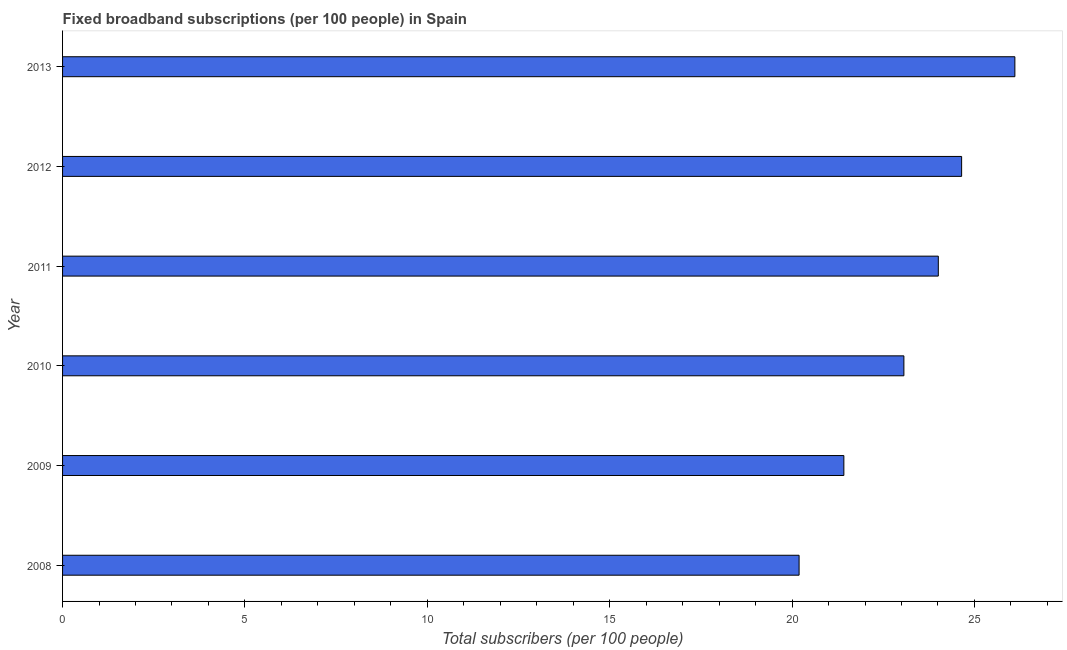Does the graph contain any zero values?
Your response must be concise. No. Does the graph contain grids?
Keep it short and to the point. No. What is the title of the graph?
Provide a succinct answer. Fixed broadband subscriptions (per 100 people) in Spain. What is the label or title of the X-axis?
Offer a very short reply. Total subscribers (per 100 people). What is the total number of fixed broadband subscriptions in 2012?
Your response must be concise. 24.65. Across all years, what is the maximum total number of fixed broadband subscriptions?
Ensure brevity in your answer.  26.11. Across all years, what is the minimum total number of fixed broadband subscriptions?
Your response must be concise. 20.19. In which year was the total number of fixed broadband subscriptions maximum?
Your answer should be very brief. 2013. What is the sum of the total number of fixed broadband subscriptions?
Ensure brevity in your answer.  139.45. What is the difference between the total number of fixed broadband subscriptions in 2010 and 2012?
Offer a terse response. -1.58. What is the average total number of fixed broadband subscriptions per year?
Give a very brief answer. 23.24. What is the median total number of fixed broadband subscriptions?
Offer a very short reply. 23.54. In how many years, is the total number of fixed broadband subscriptions greater than 11 ?
Provide a short and direct response. 6. Do a majority of the years between 2009 and 2011 (inclusive) have total number of fixed broadband subscriptions greater than 23 ?
Make the answer very short. Yes. What is the ratio of the total number of fixed broadband subscriptions in 2009 to that in 2012?
Keep it short and to the point. 0.87. What is the difference between the highest and the second highest total number of fixed broadband subscriptions?
Your answer should be compact. 1.46. Is the sum of the total number of fixed broadband subscriptions in 2011 and 2012 greater than the maximum total number of fixed broadband subscriptions across all years?
Give a very brief answer. Yes. What is the difference between the highest and the lowest total number of fixed broadband subscriptions?
Your response must be concise. 5.92. Are all the bars in the graph horizontal?
Make the answer very short. Yes. What is the difference between two consecutive major ticks on the X-axis?
Give a very brief answer. 5. What is the Total subscribers (per 100 people) of 2008?
Offer a very short reply. 20.19. What is the Total subscribers (per 100 people) in 2009?
Make the answer very short. 21.42. What is the Total subscribers (per 100 people) in 2010?
Your answer should be very brief. 23.07. What is the Total subscribers (per 100 people) in 2011?
Give a very brief answer. 24.01. What is the Total subscribers (per 100 people) in 2012?
Ensure brevity in your answer.  24.65. What is the Total subscribers (per 100 people) in 2013?
Your answer should be very brief. 26.11. What is the difference between the Total subscribers (per 100 people) in 2008 and 2009?
Offer a terse response. -1.23. What is the difference between the Total subscribers (per 100 people) in 2008 and 2010?
Give a very brief answer. -2.87. What is the difference between the Total subscribers (per 100 people) in 2008 and 2011?
Give a very brief answer. -3.82. What is the difference between the Total subscribers (per 100 people) in 2008 and 2012?
Make the answer very short. -4.46. What is the difference between the Total subscribers (per 100 people) in 2008 and 2013?
Offer a terse response. -5.92. What is the difference between the Total subscribers (per 100 people) in 2009 and 2010?
Keep it short and to the point. -1.65. What is the difference between the Total subscribers (per 100 people) in 2009 and 2011?
Provide a succinct answer. -2.59. What is the difference between the Total subscribers (per 100 people) in 2009 and 2012?
Offer a terse response. -3.23. What is the difference between the Total subscribers (per 100 people) in 2009 and 2013?
Provide a short and direct response. -4.69. What is the difference between the Total subscribers (per 100 people) in 2010 and 2011?
Make the answer very short. -0.94. What is the difference between the Total subscribers (per 100 people) in 2010 and 2012?
Offer a terse response. -1.58. What is the difference between the Total subscribers (per 100 people) in 2010 and 2013?
Offer a terse response. -3.04. What is the difference between the Total subscribers (per 100 people) in 2011 and 2012?
Give a very brief answer. -0.64. What is the difference between the Total subscribers (per 100 people) in 2011 and 2013?
Offer a terse response. -2.1. What is the difference between the Total subscribers (per 100 people) in 2012 and 2013?
Provide a short and direct response. -1.46. What is the ratio of the Total subscribers (per 100 people) in 2008 to that in 2009?
Your answer should be compact. 0.94. What is the ratio of the Total subscribers (per 100 people) in 2008 to that in 2010?
Your answer should be compact. 0.88. What is the ratio of the Total subscribers (per 100 people) in 2008 to that in 2011?
Provide a succinct answer. 0.84. What is the ratio of the Total subscribers (per 100 people) in 2008 to that in 2012?
Your answer should be very brief. 0.82. What is the ratio of the Total subscribers (per 100 people) in 2008 to that in 2013?
Provide a short and direct response. 0.77. What is the ratio of the Total subscribers (per 100 people) in 2009 to that in 2010?
Offer a very short reply. 0.93. What is the ratio of the Total subscribers (per 100 people) in 2009 to that in 2011?
Your response must be concise. 0.89. What is the ratio of the Total subscribers (per 100 people) in 2009 to that in 2012?
Give a very brief answer. 0.87. What is the ratio of the Total subscribers (per 100 people) in 2009 to that in 2013?
Your answer should be very brief. 0.82. What is the ratio of the Total subscribers (per 100 people) in 2010 to that in 2011?
Your response must be concise. 0.96. What is the ratio of the Total subscribers (per 100 people) in 2010 to that in 2012?
Your answer should be very brief. 0.94. What is the ratio of the Total subscribers (per 100 people) in 2010 to that in 2013?
Your answer should be compact. 0.88. What is the ratio of the Total subscribers (per 100 people) in 2011 to that in 2013?
Make the answer very short. 0.92. What is the ratio of the Total subscribers (per 100 people) in 2012 to that in 2013?
Provide a succinct answer. 0.94. 